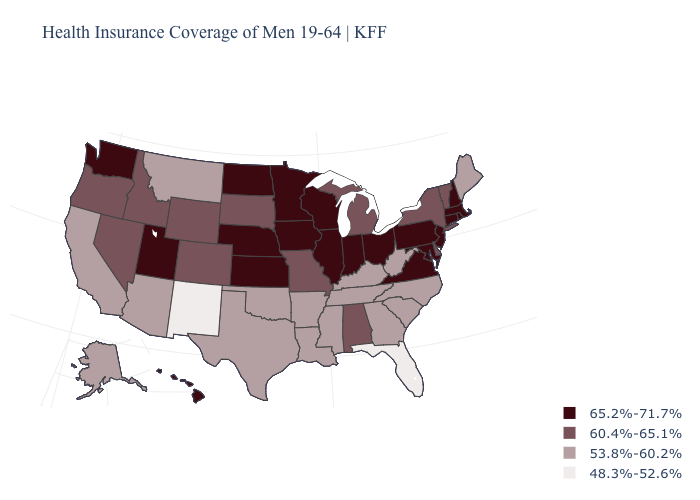Does South Dakota have a higher value than Montana?
Concise answer only. Yes. Is the legend a continuous bar?
Give a very brief answer. No. What is the value of Tennessee?
Concise answer only. 53.8%-60.2%. Name the states that have a value in the range 60.4%-65.1%?
Write a very short answer. Alabama, Colorado, Delaware, Idaho, Michigan, Missouri, Nevada, New York, Oregon, South Dakota, Vermont, Wyoming. Name the states that have a value in the range 48.3%-52.6%?
Quick response, please. Florida, New Mexico. Which states have the lowest value in the USA?
Be succinct. Florida, New Mexico. What is the value of Wyoming?
Write a very short answer. 60.4%-65.1%. Does Illinois have a higher value than Arkansas?
Concise answer only. Yes. Does the map have missing data?
Be succinct. No. Does the first symbol in the legend represent the smallest category?
Keep it brief. No. What is the highest value in the USA?
Be succinct. 65.2%-71.7%. Does Tennessee have the highest value in the South?
Quick response, please. No. What is the value of Maine?
Write a very short answer. 53.8%-60.2%. Is the legend a continuous bar?
Keep it brief. No. Does Rhode Island have the same value as Utah?
Concise answer only. Yes. 